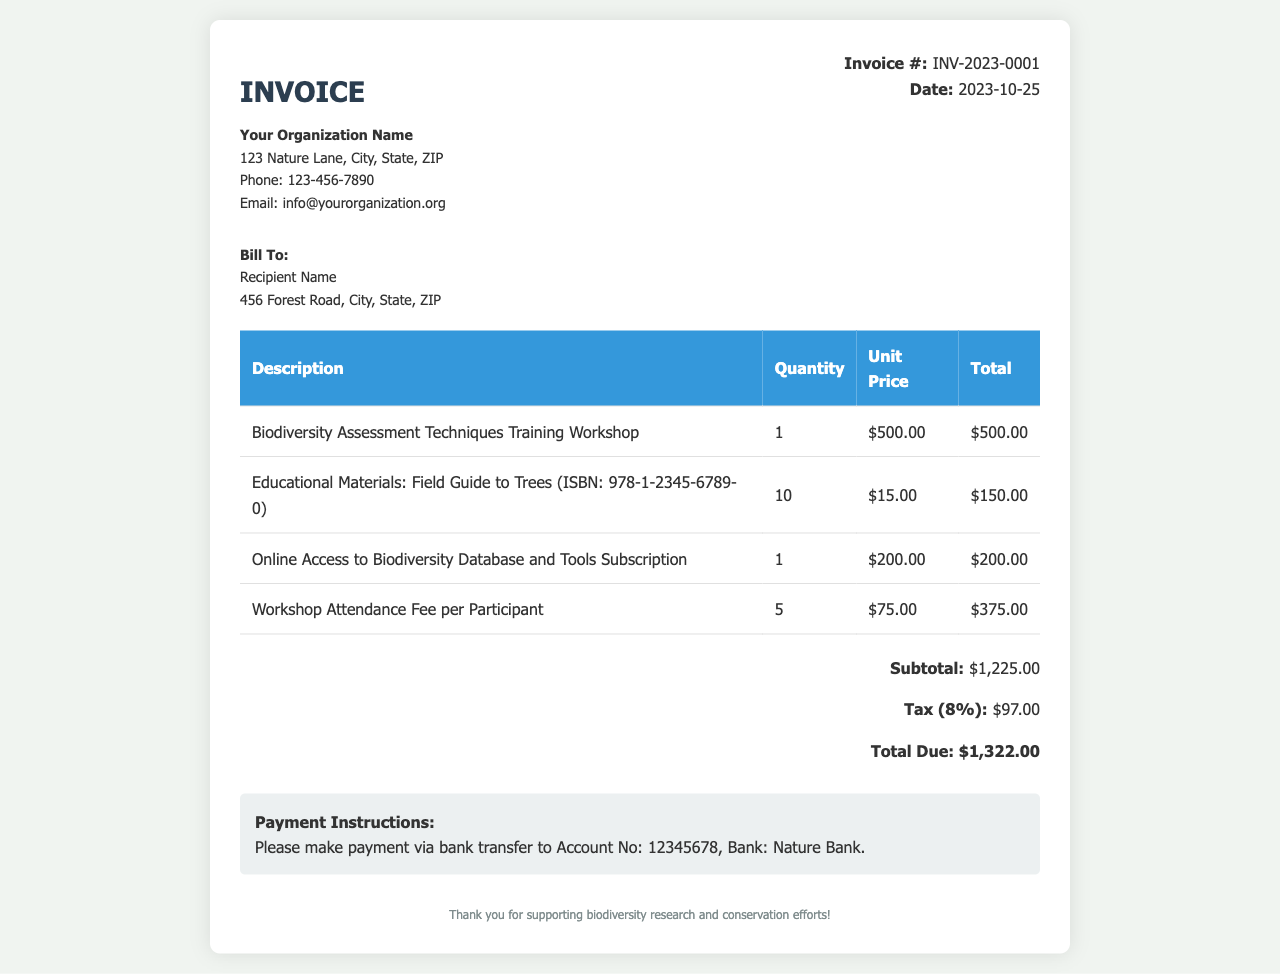What is the invoice number? The invoice number is specified in the document as a unique identifier for this transaction.
Answer: INV-2023-0001 What is the date of the invoice? The date is clearly mentioned in the invoice, indicating when it was issued.
Answer: 2023-10-25 Who is the recipient of the invoice? The recipient's name is mentioned under the "Bill To" section, which provides information on who the invoice is addressed to.
Answer: Recipient Name What is the subtotal amount? The subtotal is stated as the sum of the individual items before tax is applied, providing an overview of the cost of services and products.
Answer: $1,225.00 How much is the tax amount? The tax rate is applied to the subtotal, and the document explicitly mentions this amount.
Answer: $97.00 How many participants are included in the workshop attendance fee? The quantity listed for the workshop attendance fee indicates how many individuals this fee covers.
Answer: 5 What is included in the invoice for educational materials? The invoice details the specific educational materials provided, including titles and quantities, indicating what the charges are for.
Answer: Field Guide to Trees What payment method is specified in the invoice? The invoice offers specific instructions on how to make the payment, detailing the method of transaction.
Answer: Bank transfer What is the total due amount? The total due reflects the complete amount that needs to be paid after including the subtotal and tax, summarizing the financial obligation.
Answer: $1,322.00 